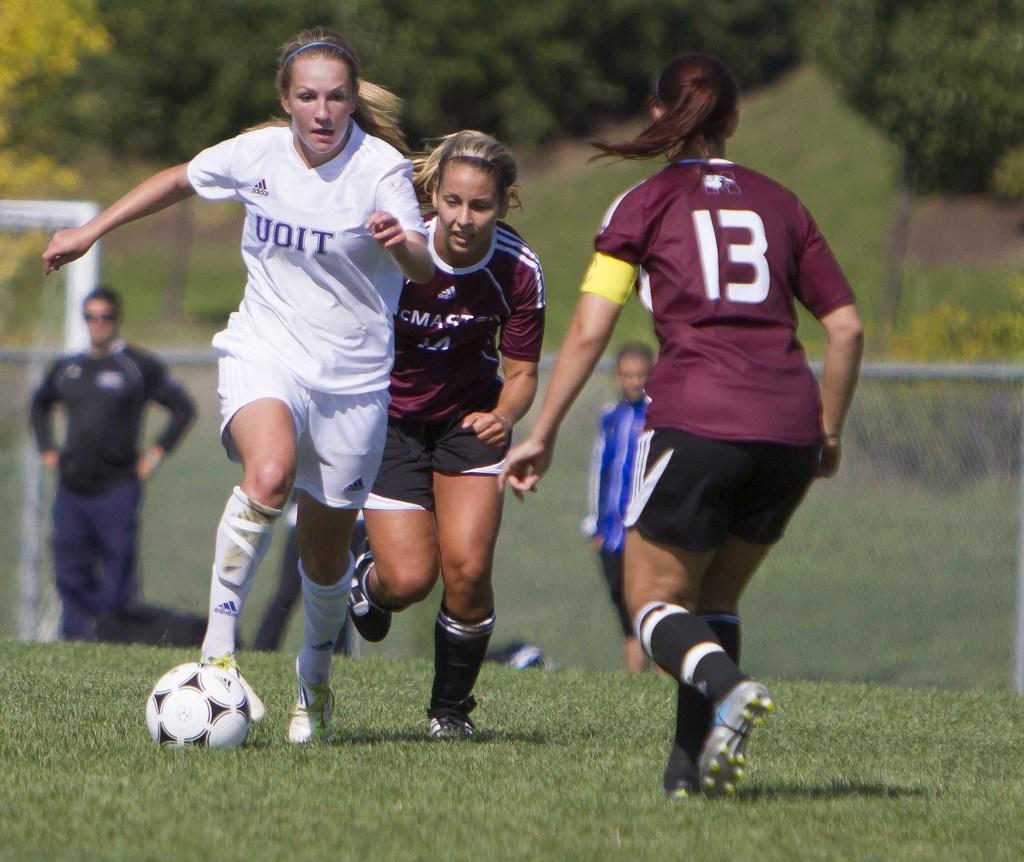Can you describe this image briefly? There are three ladies running on the ground. They are playing football. A lady with white t-shirt is kicking the ball. And there are another two ladies with violet color t-shirt. In the background there is a man with black t-shirt is standing and there are trees. 